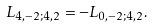<formula> <loc_0><loc_0><loc_500><loc_500>L _ { 4 , - 2 ; 4 , 2 } = - L _ { 0 , - 2 ; 4 , 2 } .</formula> 